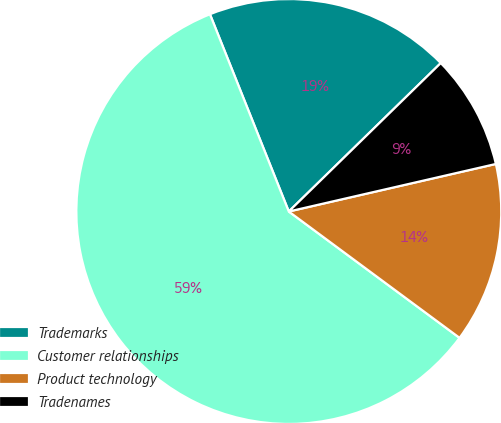<chart> <loc_0><loc_0><loc_500><loc_500><pie_chart><fcel>Trademarks<fcel>Customer relationships<fcel>Product technology<fcel>Tradenames<nl><fcel>18.74%<fcel>58.81%<fcel>13.73%<fcel>8.72%<nl></chart> 